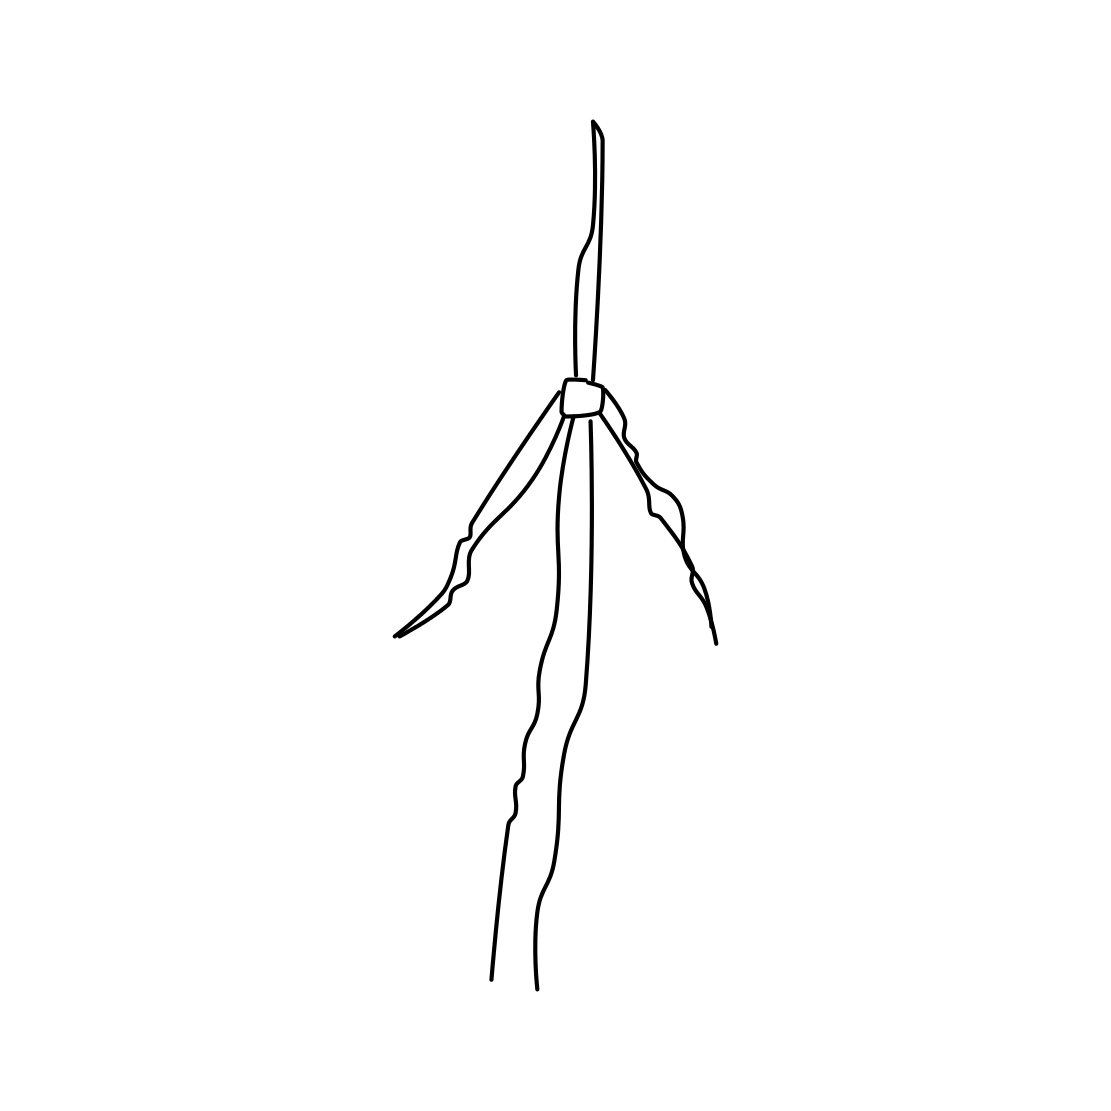Could this drawing be seen as an abstraction of something technological? Certainly, the image could be viewed as an abstract representation of technology, perhaps a simplified rendering of a communications tower or a conceptual design for a modern structure built for efficiency. Its bare form evokes a sense of streamlined innovation and could be symbolic of technological progress or minimalist design principles. 